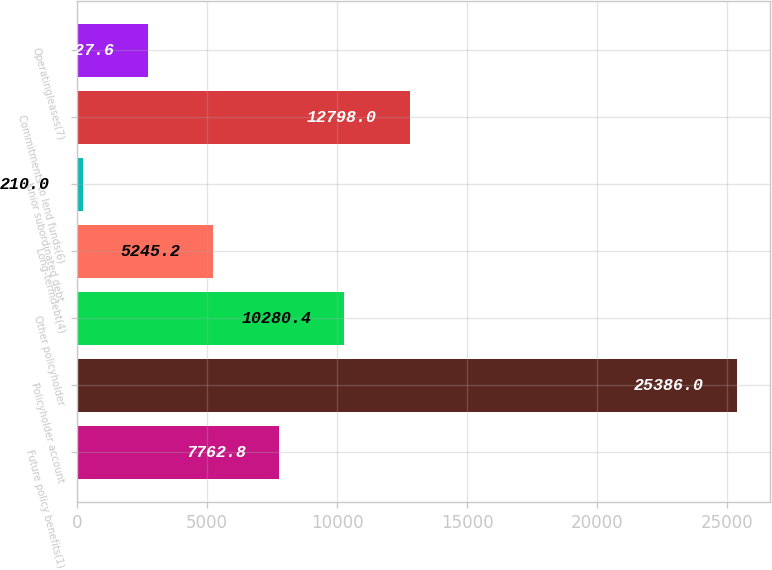Convert chart. <chart><loc_0><loc_0><loc_500><loc_500><bar_chart><fcel>Future policy benefits(1)<fcel>Policyholder account<fcel>Other policyholder<fcel>Long-termdebt(4)<fcel>Junior subordinated debt<fcel>Commitments to lend funds(6)<fcel>Operatingleases(7)<nl><fcel>7762.8<fcel>25386<fcel>10280.4<fcel>5245.2<fcel>210<fcel>12798<fcel>2727.6<nl></chart> 